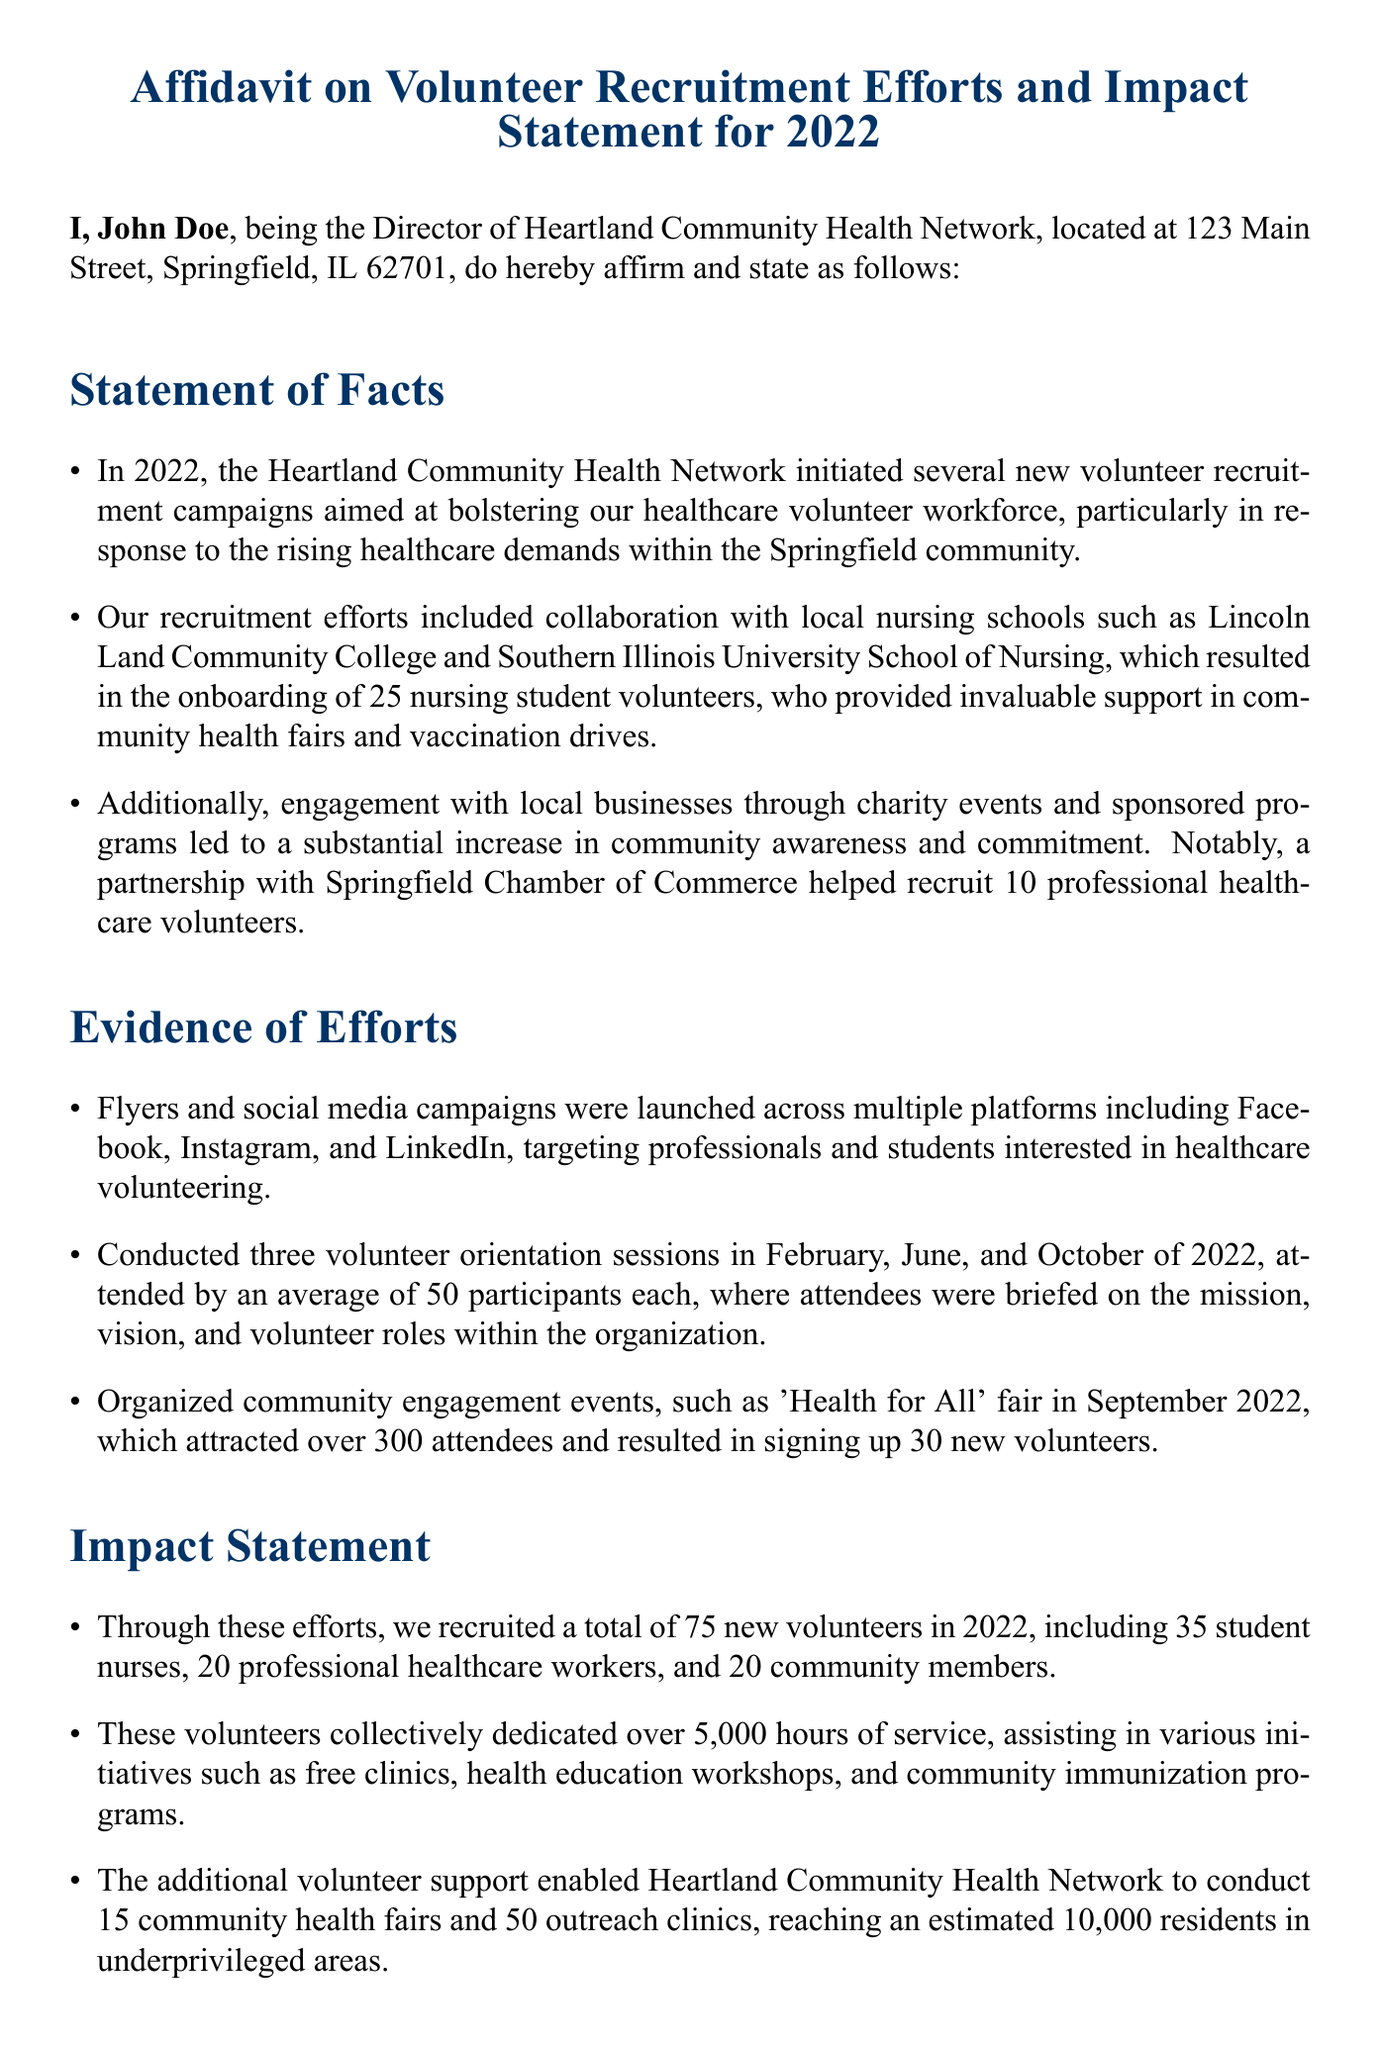What is the name of the organization? The organization mentioned in the affidavit is Heartland Community Health Network.
Answer: Heartland Community Health Network How many nursing student volunteers were recruited? The document states that 25 nursing student volunteers were onboarded during recruitment efforts.
Answer: 25 What event attracted over 300 attendees? The event referenced in the affidavit is the 'Health for All' fair held in September 2022.
Answer: 'Health for All' fair How many volunteer orientation sessions were conducted in 2022? The affidavit indicates that three volunteer orientation sessions were held in February, June, and October of 2022.
Answer: three What was the total number of new volunteers recruited in 2022? The document mentions that a total of 75 new volunteers were recruited throughout the year.
Answer: 75 What was the total number of hours dedicated by volunteers? According to the affidavit, volunteers collectively dedicated over 5,000 hours of service.
Answer: 5000 What partnership helped recruit 10 professional healthcare volunteers? The Springfield Chamber of Commerce partnership was instrumental in recruiting those volunteers.
Answer: Springfield Chamber of Commerce What is the date of the affidavit? The affidavit is dated January 28, 2023.
Answer: January 28, 2023 What kind of events were conducted to engage the community? The affidavit lists community engagement events, particularly health fairs and outreach clinics.
Answer: Health fairs and outreach clinics 